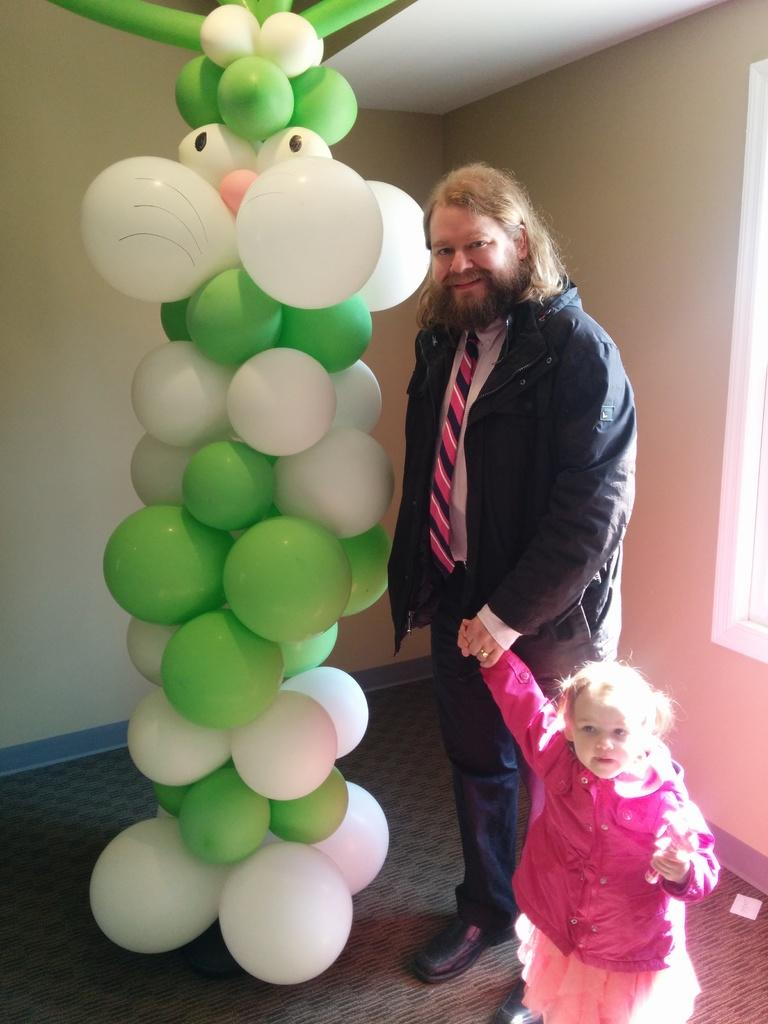Who are the people in the image? There is a man and a girl in the image. What are the man and the girl doing in the image? Both the man and the girl are standing on the floor. What can be seen in the image besides the people? There are balloons in the image. What colors are the balloons? The balloons are green and white in color. What is visible in the background of the image? There is a wall in the background of the image. How many giants are present in the image? There are no giants present in the image. What type of payment method is being used by the snail in the image? There is no snail present in the image, and therefore no payment method can be observed. 